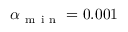<formula> <loc_0><loc_0><loc_500><loc_500>\alpha _ { m i n } = 0 . 0 0 1</formula> 